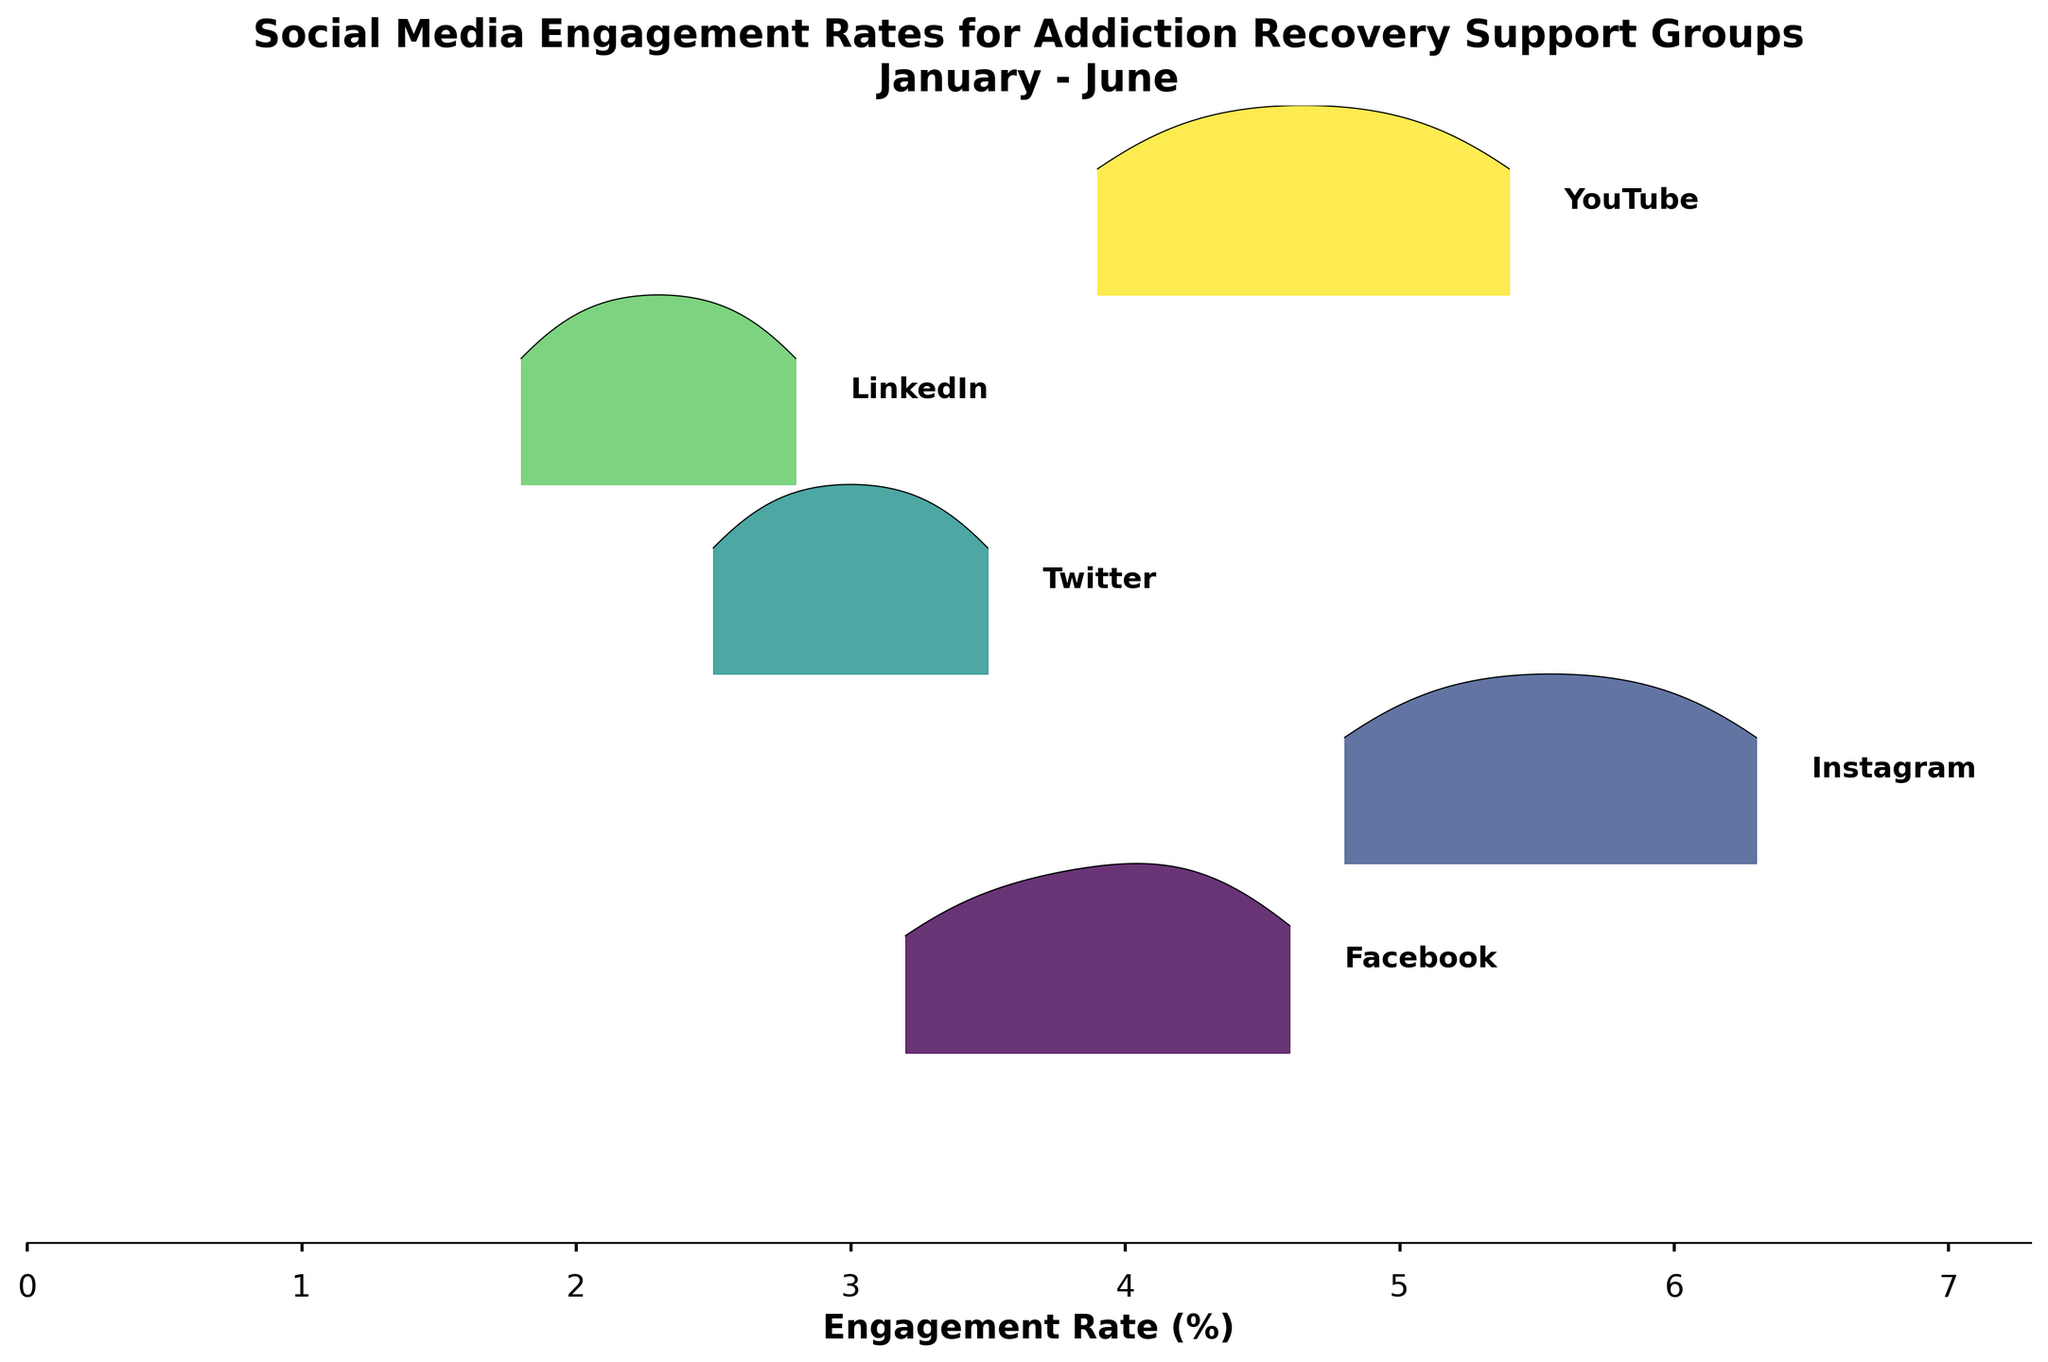What is the title of the figure? The title of a figure is usually displayed prominently at the top and summarizes the visual information presented. Here, it should be at the top center of the figure.
Answer: Social Media Engagement Rates for Addiction Recovery Support Groups January - June What is the maximum engagement rate observed in the plot? To find the maximum engagement rate, look at the x-axis, which represents engagement rates, and identify the highest value shown.
Answer: 6.3 Which platform has the highest engagement rate? By inspecting the peaks of the ridgelines, we can see that Instagram has the highest engagement rate as it reaches the maximum value on the x-axis.
Answer: Instagram Which platform has the lowest engagement rate? By inspecting the peaks and starting points of the ridgelines, we can see that LinkedIn has the lowest engagement rates since its ridgeline starts near the lowest value on the x-axis.
Answer: LinkedIn What is the range of engagement rates for YouTube in the plot? To find the range of engagement rates for YouTube, identify the minimum and maximum engagement rates for YouTube. The range can be calculated by finding their difference: 5.4 - 3.9.
Answer: 1.5 Compare the average engagement rate of Facebook and Twitter. Which one is higher? Calculate the average engagement rate for Facebook (sum of its engagement rates divided by the number of months) and do the same for Twitter. Compare the two averages. Facebook: (3.2 + 3.5 + 3.8 + 4.1 + 4.3 + 4.6)/6 = 3.92; Twitter: (2.5 + 2.7 + 2.9 + 3.1 + 3.3 + 3.5)/6 = 3.0.
Answer: Facebook How many social media platforms are represented in the plot? Count the number of unique ridgelines in the plot, each representing a different platform.
Answer: 5 Which platform shows a steady increase in engagement rates over the months? Observe the ridgelines and identify the ones where engagement rates consistently increase from left to right. All platforms demonstrate a steady increase, so the answer includes all of them.
Answer: All (Facebook, Instagram, Twitter, LinkedIn, YouTube) What is the engagement rate for Instagram in March? Locate the ridgeline corresponding to Instagram and find the value along the x-axis where it intersects with the label for March.
Answer: 5.4 Explain the general trend in social media engagement over the six months for one platform. Analyze the shape and position of the ridgeline for one platform, noting how it changes as months progress. For example, Instagram's engagement rate starts at 4.8 in January and steadily increases each month, reaching 6.3 in June, indicating a continuous rise in engagement.
Answer: Continuous rise 